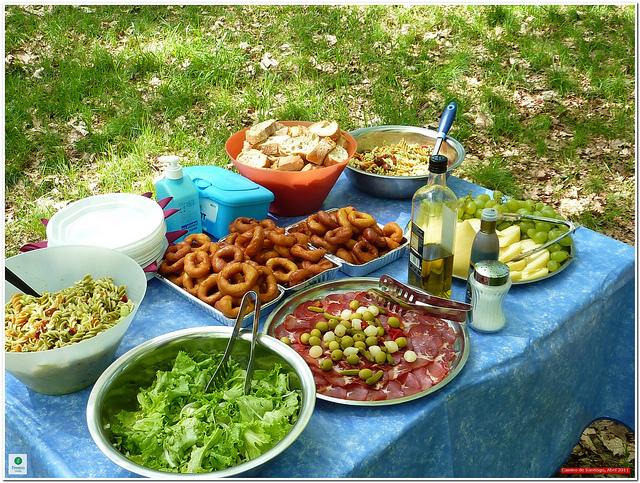Has the meal started yet?
Keep it brief. No. What meal is this?
Answer briefly. Lunch. How many bowls are on the table?
Give a very brief answer. 4. Is there any plates on the table?
Answer briefly. Yes. 